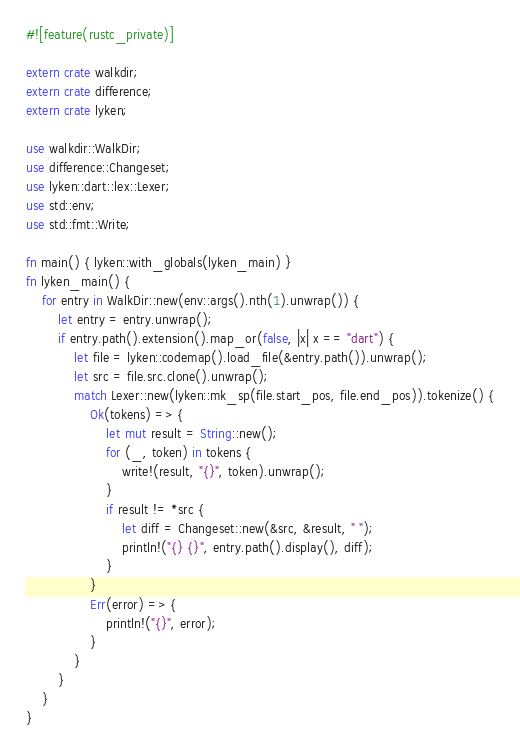Convert code to text. <code><loc_0><loc_0><loc_500><loc_500><_Rust_>#![feature(rustc_private)]

extern crate walkdir;
extern crate difference;
extern crate lyken;

use walkdir::WalkDir;
use difference::Changeset;
use lyken::dart::lex::Lexer;
use std::env;
use std::fmt::Write;

fn main() { lyken::with_globals(lyken_main) }
fn lyken_main() {
    for entry in WalkDir::new(env::args().nth(1).unwrap()) {
        let entry = entry.unwrap();
        if entry.path().extension().map_or(false, |x| x == "dart") {
            let file = lyken::codemap().load_file(&entry.path()).unwrap();
            let src = file.src.clone().unwrap();
            match Lexer::new(lyken::mk_sp(file.start_pos, file.end_pos)).tokenize() {
                Ok(tokens) => {
                    let mut result = String::new();
                    for (_, token) in tokens {
                        write!(result, "{}", token).unwrap();
                    }
                    if result != *src {
                        let diff = Changeset::new(&src, &result, " ");
                        println!("{} {}", entry.path().display(), diff);
                    }
                }
                Err(error) => {
                    println!("{}", error);
                }
            }
        }
    }
}
</code> 